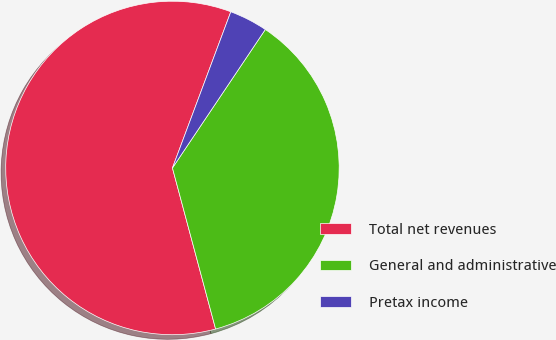Convert chart. <chart><loc_0><loc_0><loc_500><loc_500><pie_chart><fcel>Total net revenues<fcel>General and administrative<fcel>Pretax income<nl><fcel>59.86%<fcel>36.43%<fcel>3.71%<nl></chart> 